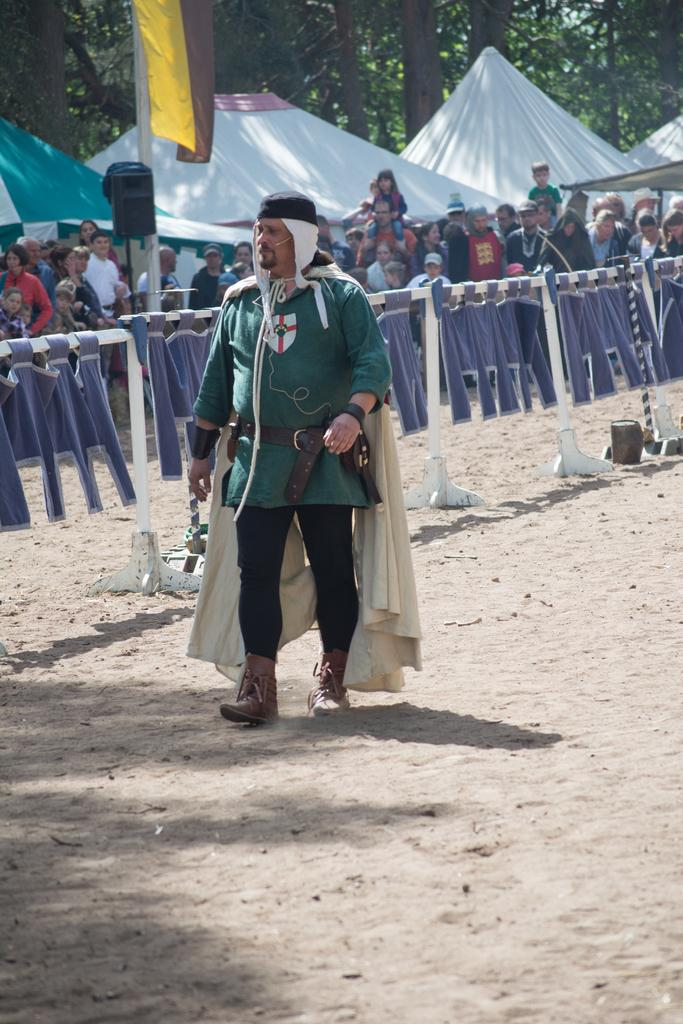What is the person in the image doing? The person is walking on the sand. What is the person wearing on their head? The person is wearing a cap. What color is the person's shirt? The person is wearing a green shirt. What color are the person's pants? The person is wearing black pants. What type of footwear is the person wearing? The person is wearing boots. What can be seen in the background of the image? There is a fence, flags, people, tents, and trees in the image. What type of quiver is the person carrying in the image? There is no quiver present in the image. What type of drink is the person holding in the image? There is no drink present in the image. What time of day is it in the image? The provided facts do not give information about the time of day, so we cannot determine the hour from the image. 